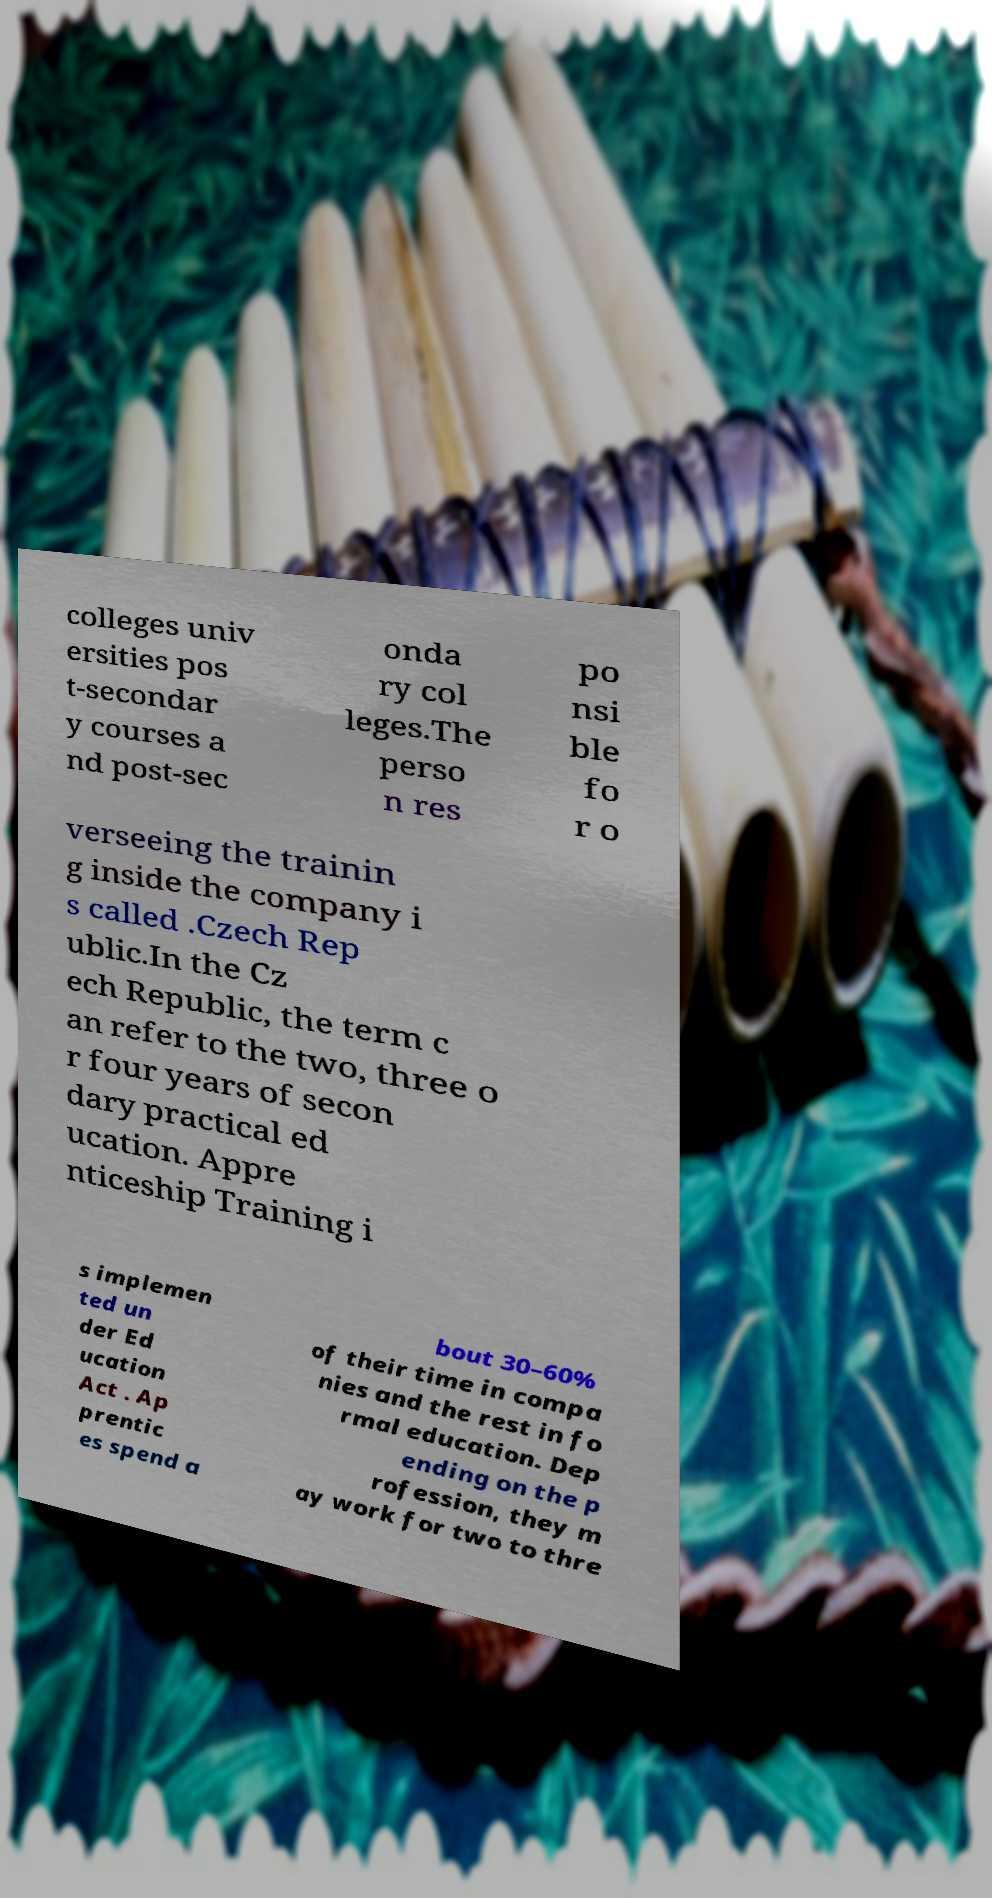Can you accurately transcribe the text from the provided image for me? colleges univ ersities pos t-secondar y courses a nd post-sec onda ry col leges.The perso n res po nsi ble fo r o verseeing the trainin g inside the company i s called .Czech Rep ublic.In the Cz ech Republic, the term c an refer to the two, three o r four years of secon dary practical ed ucation. Appre nticeship Training i s implemen ted un der Ed ucation Act . Ap prentic es spend a bout 30–60% of their time in compa nies and the rest in fo rmal education. Dep ending on the p rofession, they m ay work for two to thre 